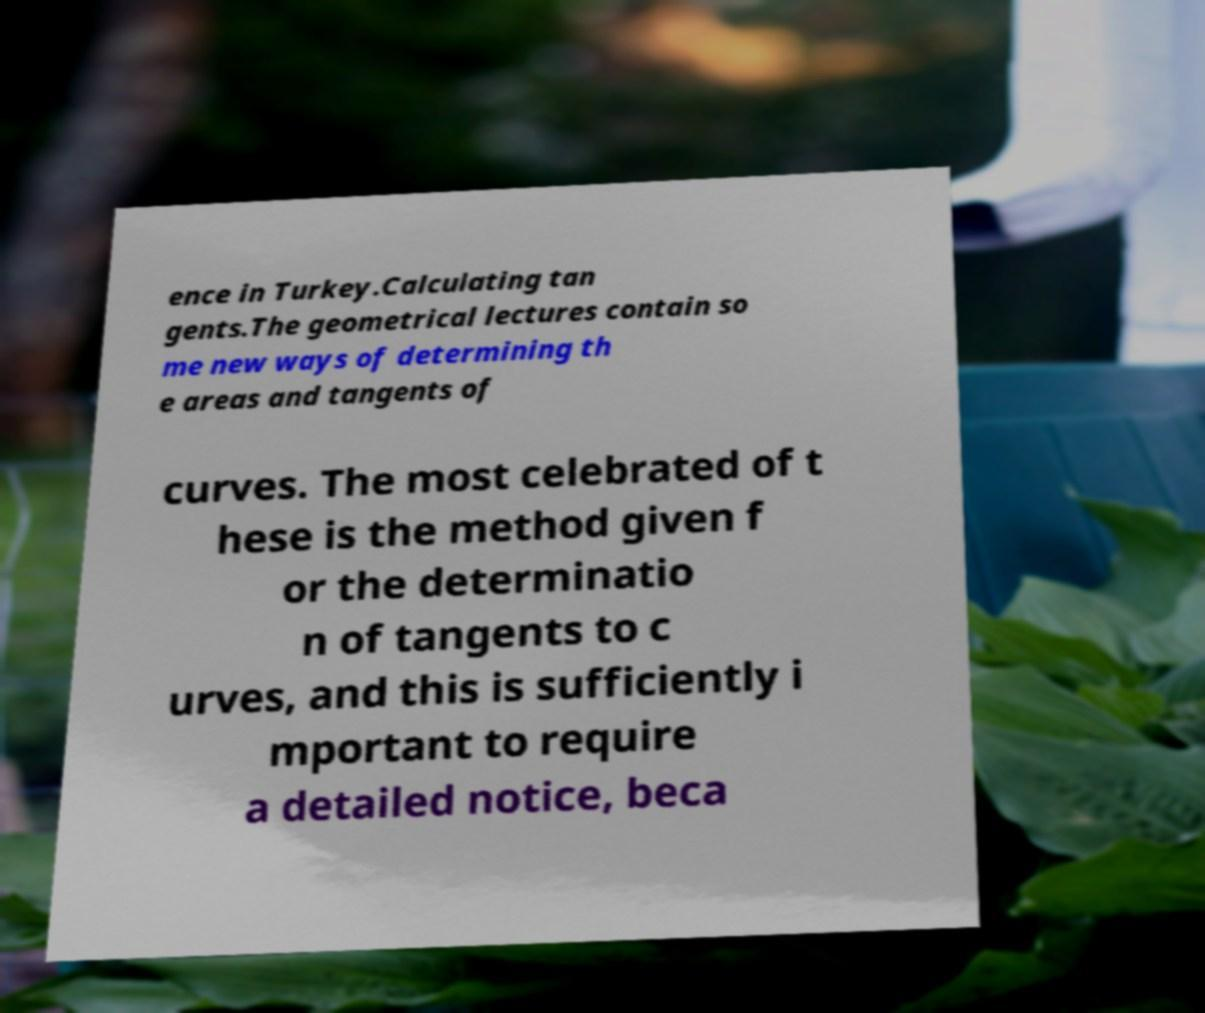I need the written content from this picture converted into text. Can you do that? ence in Turkey.Calculating tan gents.The geometrical lectures contain so me new ways of determining th e areas and tangents of curves. The most celebrated of t hese is the method given f or the determinatio n of tangents to c urves, and this is sufficiently i mportant to require a detailed notice, beca 